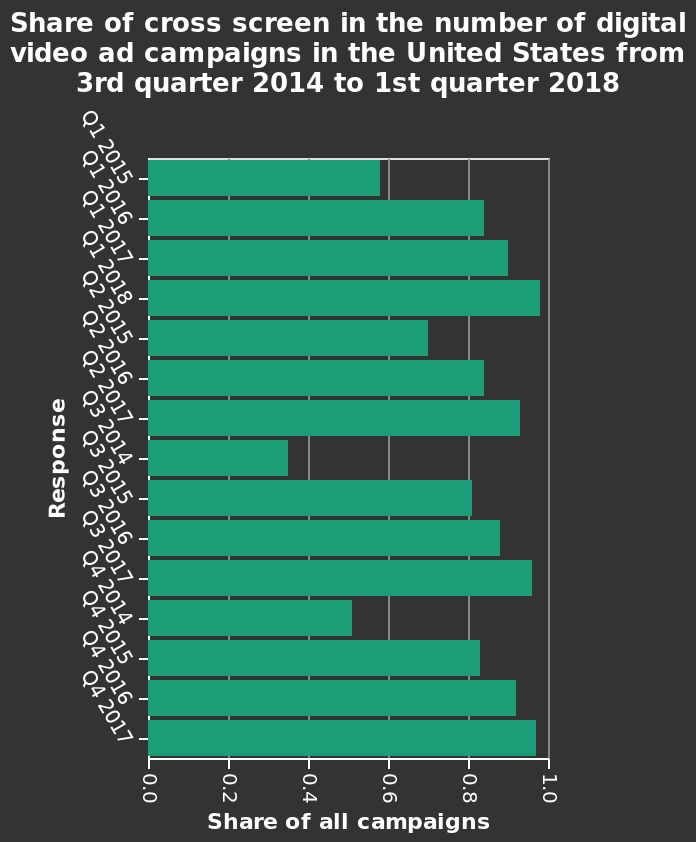<image>
What is the general feeling of the person towards this graph? The person is frustrated or perplexed by this graph. please enumerates aspects of the construction of the chart This bar graph is labeled Share of cross screen in the number of digital video ad campaigns in the United States from 3rd quarter 2014 to 1st quarter 2018. The y-axis measures Response while the x-axis shows Share of all campaigns. What does the person want to do with the graph? The person wants to analyze or interpret the graph but is unable to do so. What does the x-axis represent in this bar graph?  The x-axis represents the "Share of all campaigns" in the number of digital video ad campaigns in the United States. please summary the statistics and relations of the chart There is significant variance in share of cross screen but it looks to follow a three to four year pattern - dropping to a low and rising to a peak before dropping again. 